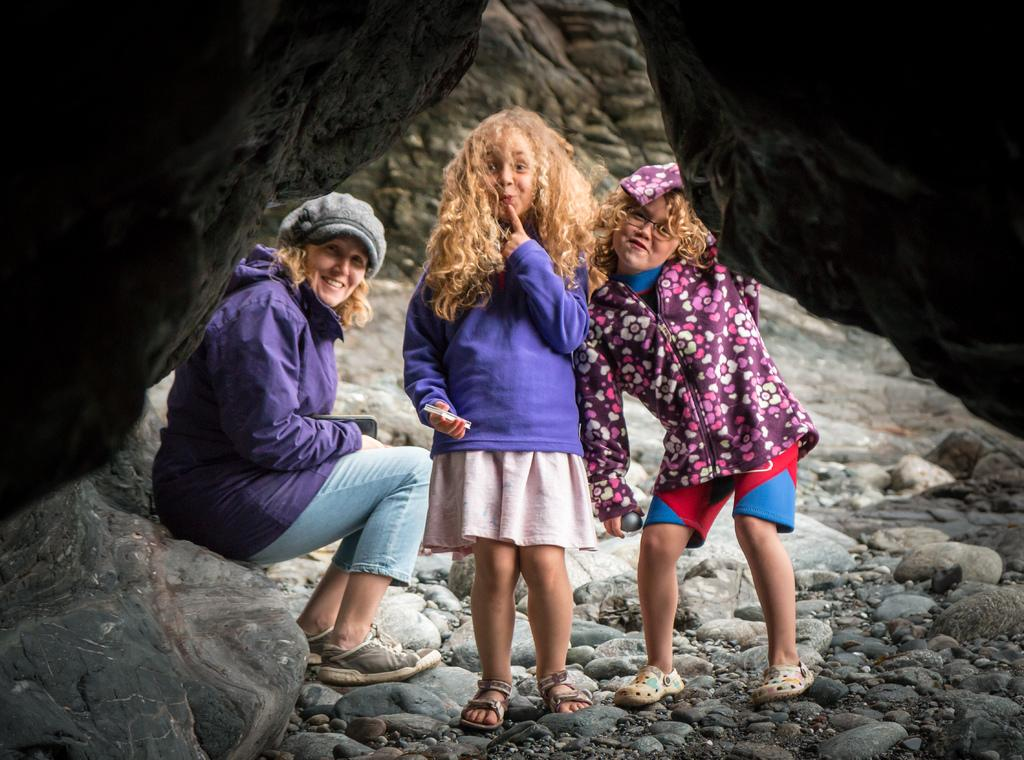What is the main subject in the foreground of the image? There are people in the foreground of the image. What are the people standing on in the image? The people are on stones or rocks. Can you describe the background of the image? There are rocks or stones in the top right and left sides of the image. What type of nerve can be seen in the image? There is no nerve present in the image; it features people standing on stones or rocks. Can you tell me how many grandmothers are visible in the image? There is no grandmother present in the image; it features people standing on stones or rocks. 